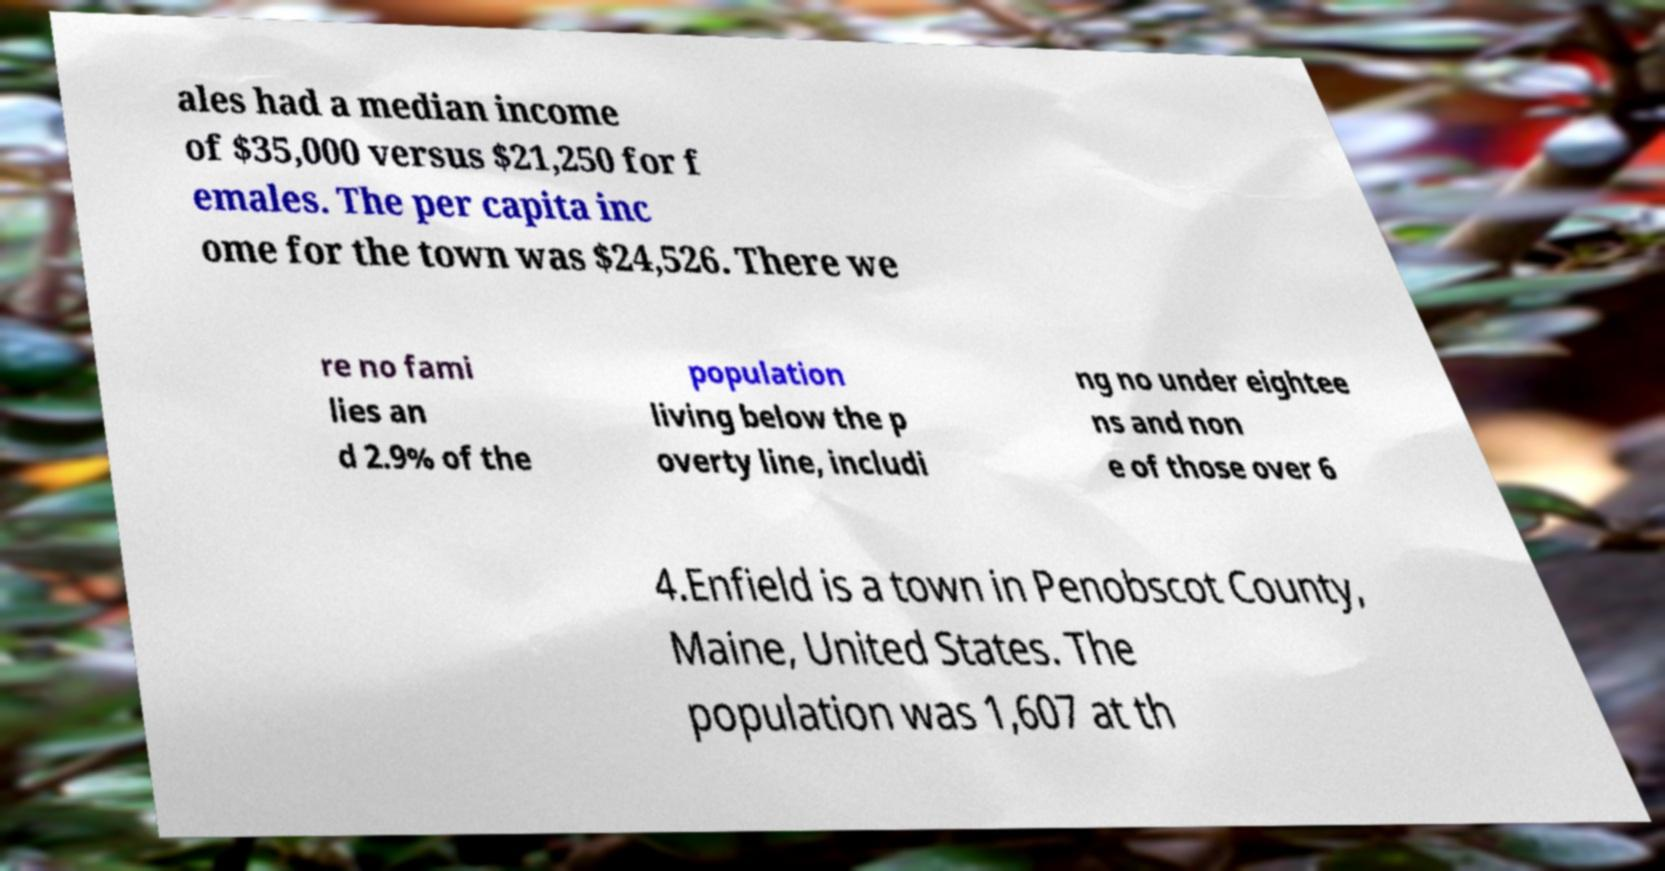For documentation purposes, I need the text within this image transcribed. Could you provide that? ales had a median income of $35,000 versus $21,250 for f emales. The per capita inc ome for the town was $24,526. There we re no fami lies an d 2.9% of the population living below the p overty line, includi ng no under eightee ns and non e of those over 6 4.Enfield is a town in Penobscot County, Maine, United States. The population was 1,607 at th 